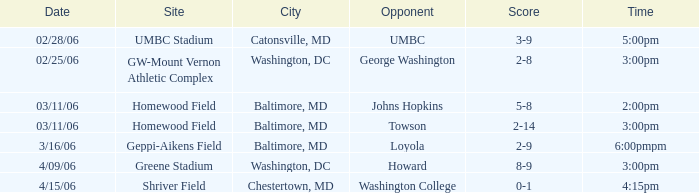Which Score has a Time of 5:00pm? 3-9. 